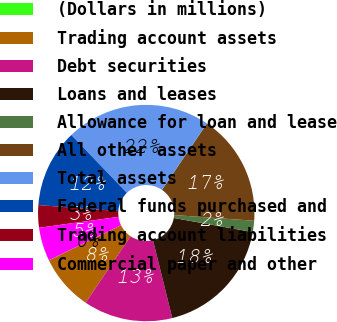Convert chart. <chart><loc_0><loc_0><loc_500><loc_500><pie_chart><fcel>(Dollars in millions)<fcel>Trading account assets<fcel>Debt securities<fcel>Loans and leases<fcel>Allowance for loan and lease<fcel>All other assets<fcel>Total assets<fcel>Federal funds purchased and<fcel>Trading account liabilities<fcel>Commercial paper and other<nl><fcel>0.02%<fcel>8.34%<fcel>13.33%<fcel>18.32%<fcel>1.68%<fcel>16.66%<fcel>21.65%<fcel>11.66%<fcel>3.34%<fcel>5.01%<nl></chart> 